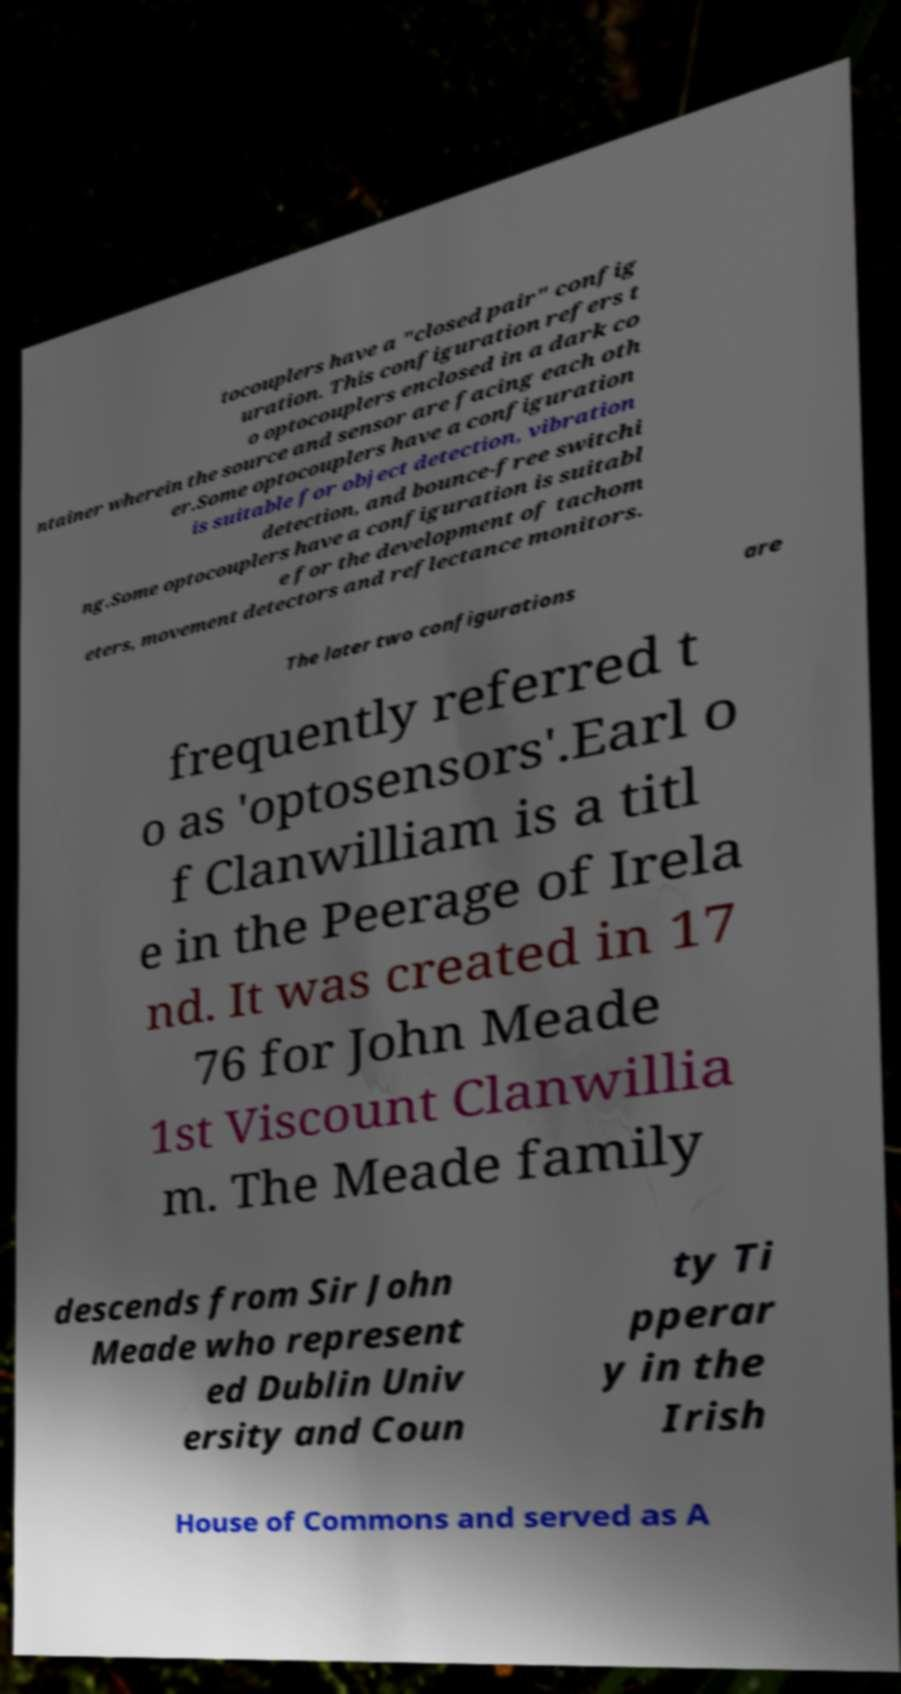Could you extract and type out the text from this image? tocouplers have a "closed pair" config uration. This configuration refers t o optocouplers enclosed in a dark co ntainer wherein the source and sensor are facing each oth er.Some optocouplers have a configuration is suitable for object detection, vibration detection, and bounce-free switchi ng.Some optocouplers have a configuration is suitabl e for the development of tachom eters, movement detectors and reflectance monitors. The later two configurations are frequently referred t o as 'optosensors'.Earl o f Clanwilliam is a titl e in the Peerage of Irela nd. It was created in 17 76 for John Meade 1st Viscount Clanwillia m. The Meade family descends from Sir John Meade who represent ed Dublin Univ ersity and Coun ty Ti pperar y in the Irish House of Commons and served as A 